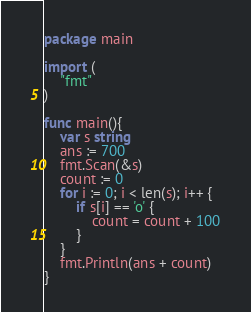Convert code to text. <code><loc_0><loc_0><loc_500><loc_500><_Go_>package main

import (
	"fmt"
)

func main(){
	var s string
	ans := 700
	fmt.Scan(&s)
	count := 0
	for i := 0; i < len(s); i++ {
		if s[i] == 'o' {
			count = count + 100
		}
	}
	fmt.Println(ans + count)
}</code> 